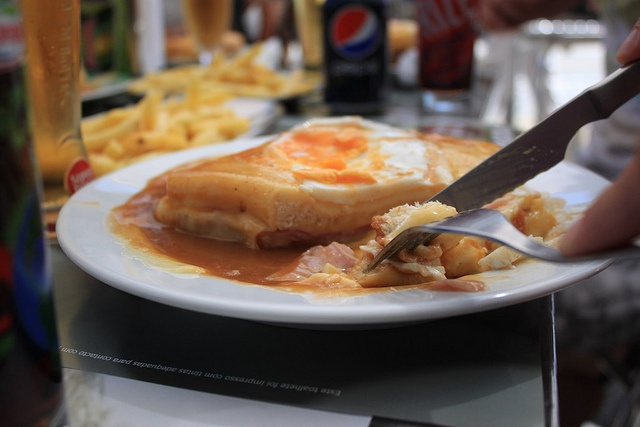Describe the objects in this image and their specific colors. I can see dining table in darkgreen, black, darkgray, gray, and brown tones, bottle in darkgreen, black, gray, navy, and maroon tones, bottle in darkgreen, maroon, brown, and gray tones, bottle in darkgreen, black, maroon, and gray tones, and knife in darkgreen, black, and gray tones in this image. 